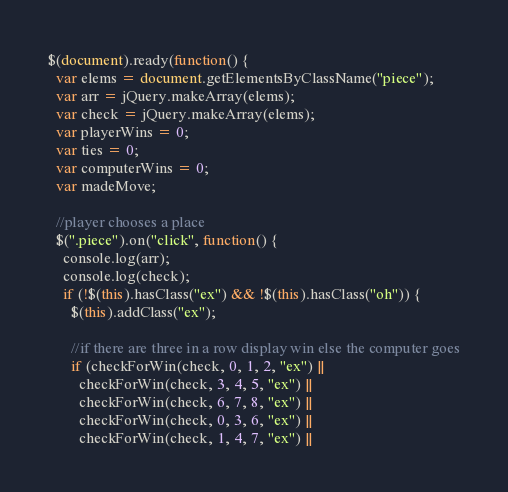<code> <loc_0><loc_0><loc_500><loc_500><_JavaScript_>$(document).ready(function() {
  var elems = document.getElementsByClassName("piece");
  var arr = jQuery.makeArray(elems);
  var check = jQuery.makeArray(elems);
  var playerWins = 0;
  var ties = 0;
  var computerWins = 0;
  var madeMove;

  //player chooses a place
  $(".piece").on("click", function() {
    console.log(arr);
    console.log(check);
    if (!$(this).hasClass("ex") && !$(this).hasClass("oh")) {
      $(this).addClass("ex");

      //if there are three in a row display win else the computer goes
      if (checkForWin(check, 0, 1, 2, "ex") ||
        checkForWin(check, 3, 4, 5, "ex") ||
        checkForWin(check, 6, 7, 8, "ex") ||
        checkForWin(check, 0, 3, 6, "ex") ||
        checkForWin(check, 1, 4, 7, "ex") ||</code> 